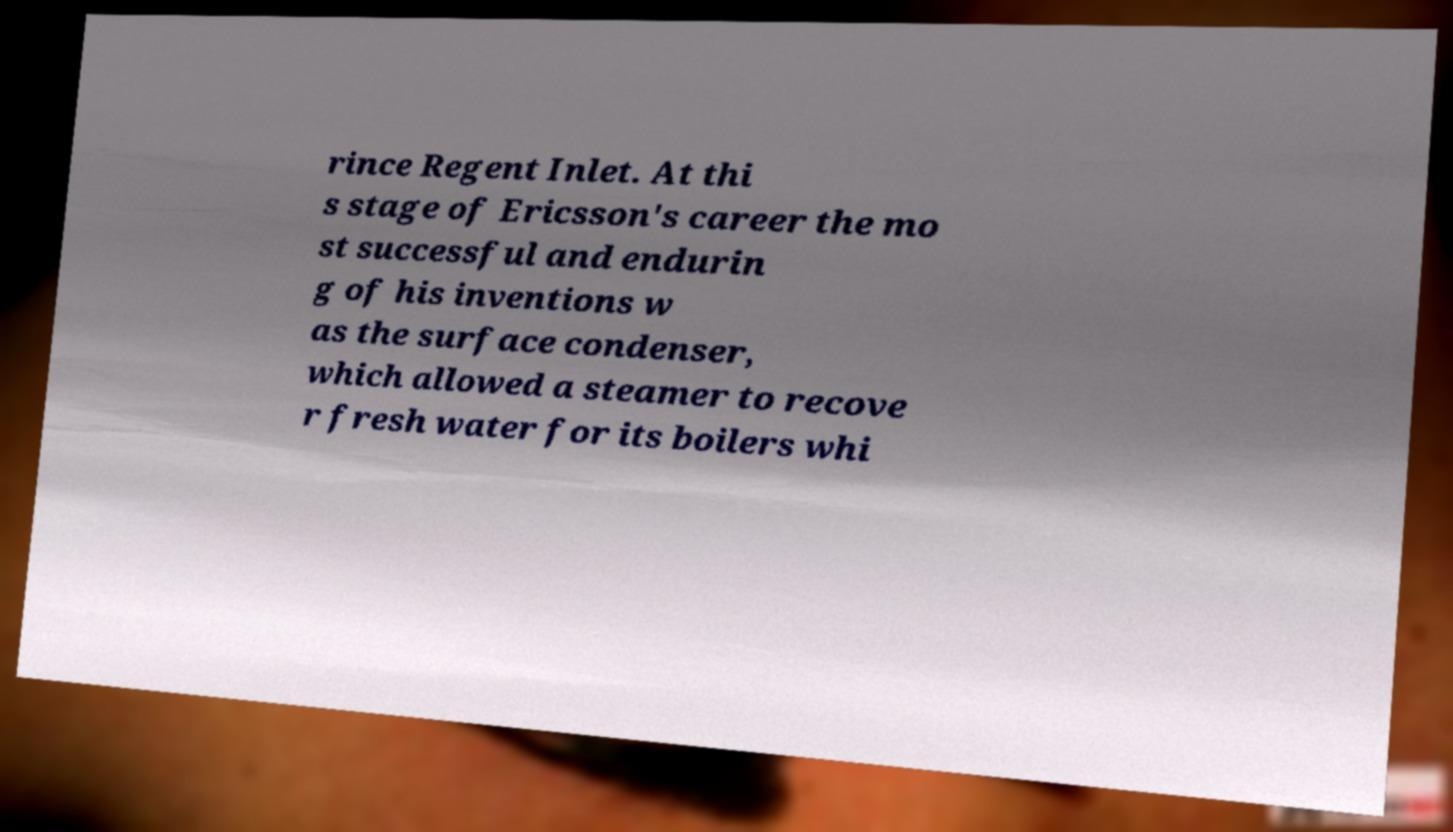Could you extract and type out the text from this image? rince Regent Inlet. At thi s stage of Ericsson's career the mo st successful and endurin g of his inventions w as the surface condenser, which allowed a steamer to recove r fresh water for its boilers whi 